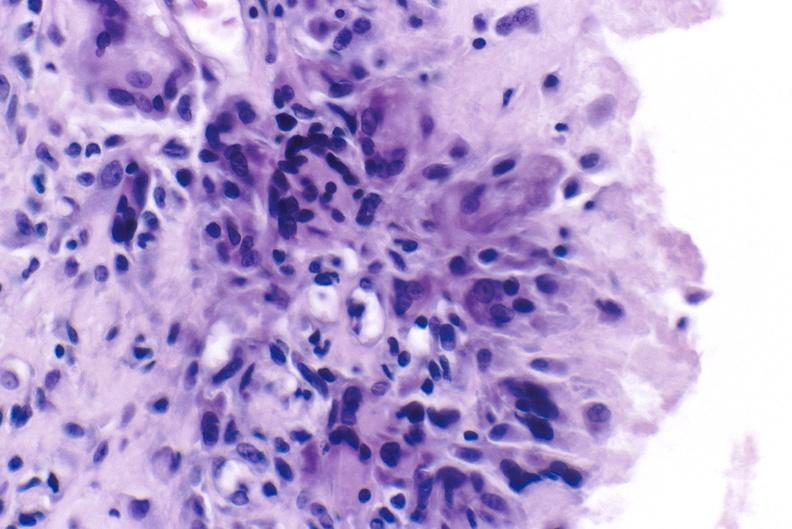does inflamed exocervix show gout?
Answer the question using a single word or phrase. No 